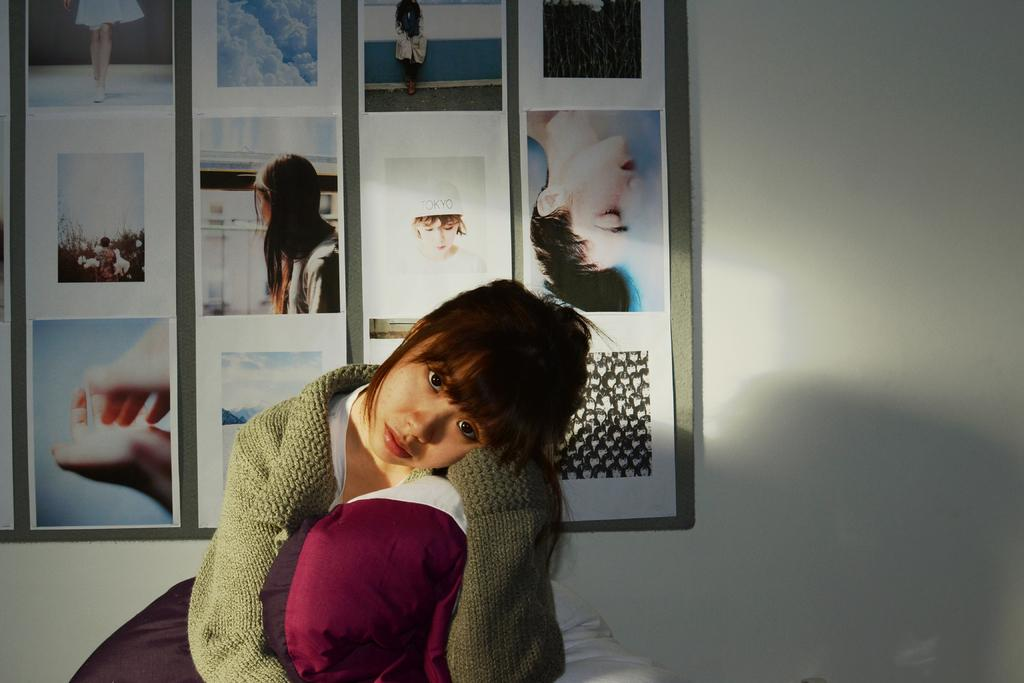Who is the main subject in the image? There is a lady in the image. What is the lady doing in the image? The lady is sitting. What is the lady wearing in the image? The lady is wearing a green sweater. What can be seen in the background of the image? There is a frame in the background of the image. What is inside the frame in the image? The frame contains many pictures. How does the lady smash the pictures in the frame in the image? The lady does not smash the pictures in the frame in the image; there is no indication of any destructive behavior. 